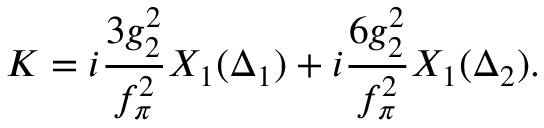Convert formula to latex. <formula><loc_0><loc_0><loc_500><loc_500>K = i \frac { 3 g _ { 2 } ^ { 2 } } { f _ { \pi } ^ { 2 } } X _ { 1 } ( \Delta _ { 1 } ) + i \frac { 6 g _ { 2 } ^ { 2 } } { f _ { \pi } ^ { 2 } } X _ { 1 } ( \Delta _ { 2 } ) .</formula> 